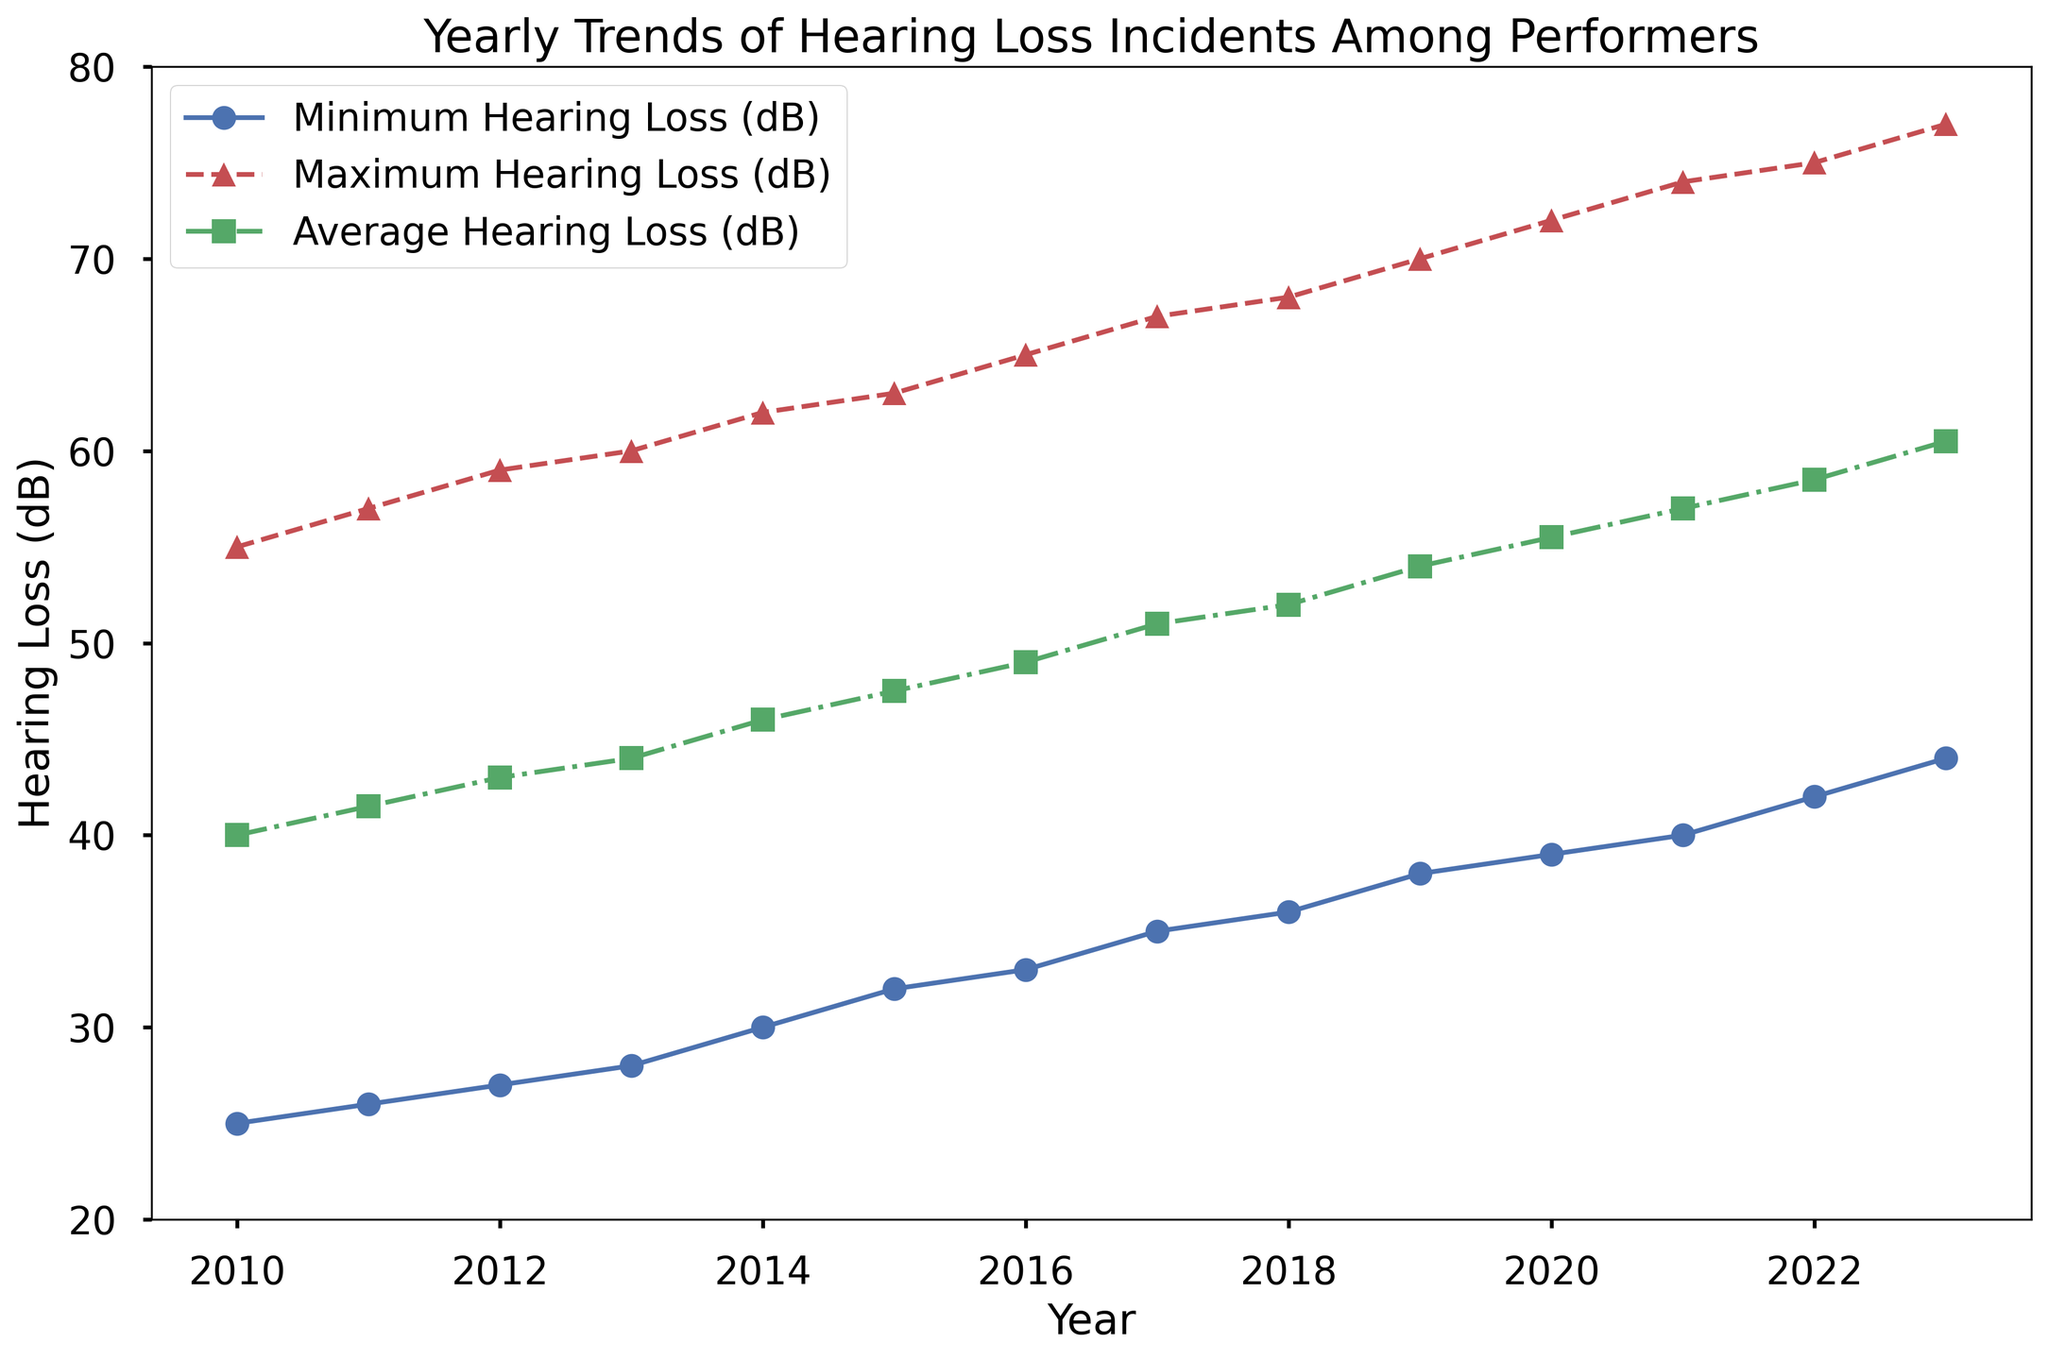Which year had the highest average hearing loss? Look for the highest point on the green-colored line representing 'Average Hearing Loss (dB)'. The peak of this line occurs in the year 2023.
Answer: 2023 What was the minimum hearing loss in 2013? Locate the data point for the blue-colored line representing 'Minimum Hearing Loss (dB)' at the year 2013. It shows 28 dB.
Answer: 28 dB By how many decibels did the maximum hearing loss increase from 2019 to 2023? Find the 'Maximum Hearing Loss (dB)' values for both years on the red-colored line. In 2019, it was 70 dB, and in 2023, it was 77 dB. Subtract 70 from 77.
Answer: 7 dB Which year had the smallest difference between minimum and maximum hearing loss? For each year, calculate the difference between the 'Maximum Hearing Loss' value (red line) and the 'Minimum Hearing Loss' value (blue line). The smallest difference is in 2010, where the difference is 30 dB (55 - 25).
Answer: 2010 Between which consecutive years was the increase in average hearing loss the greatest? Compare the 'Average Hearing Loss (dB)' values for each consecutive year. The largest increase is from 2022 to 2023, going from 58.5 dB to 60.5 dB (an increase of 2 dB).
Answer: 2022 to 2023 What is the trend of minimum hearing loss from 2010 to 2023? Observe the blue-colored line for 'Minimum Hearing Loss (dB)' from 2010 to 2023. The line shows a continuous upward trend.
Answer: Increasing What is the average minimum hearing loss over the years 2010 to 2023? Sum the 'Minimum Hearing Loss (dB)' values from each year and divide by the number of years (14). The sum is (25+26+27+28+30+32+33+35+36+38+39+40+42+44) = 475 dB, and 475 / 14 = approximately 33.93 dB.
Answer: Approximately 33.93 dB In which year did the maximum hearing loss exceed 70 dB for the first time? Check the red line for 'Maximum Hearing Loss (dB)' values and find the first year it exceeds 70 dB. This occurs in 2020 with 72 dB.
Answer: 2020 What's the range of average hearing loss values between 2010 and 2023? Find the lowest and highest points on the green-colored line representing 'Average Hearing Loss (dB)'. The range is from 40 dB (in 2010) to 60.5 dB (in 2023), so the range is 20.5 dB (60.5 - 40).
Answer: 20.5 dB For which years did the minimum hearing loss increase by exactly 2 dB from the previous year? Check the blue-colored line for jumps of exactly 2 dB between consecutive years. This happens from 2014 to 2015 (30 to 32 dB), from 2016 to 2017 (33 to 35 dB), and from 2022 to 2023 (42 to 44 dB).
Answer: 2014 to 2015, 2016 to 2017, 2022 to 2023 